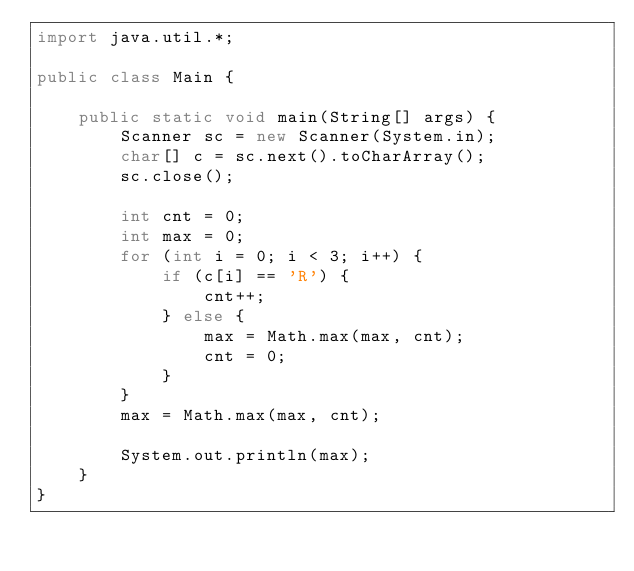<code> <loc_0><loc_0><loc_500><loc_500><_Java_>import java.util.*;

public class Main {

	public static void main(String[] args) {
		Scanner sc = new Scanner(System.in);
		char[] c = sc.next().toCharArray();
		sc.close();

		int cnt = 0;
		int max = 0;
		for (int i = 0; i < 3; i++) {
			if (c[i] == 'R') {
				cnt++;
			} else {
				max = Math.max(max, cnt);
				cnt = 0;
			}
		}
		max = Math.max(max, cnt);

		System.out.println(max);
	}
}
</code> 